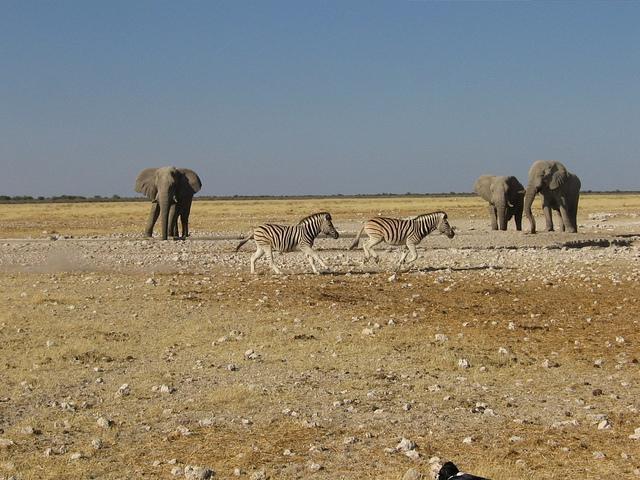How many zebras are running across the rocky field?
Choose the right answer from the provided options to respond to the question.
Options: Six, two, three, five. Two. 